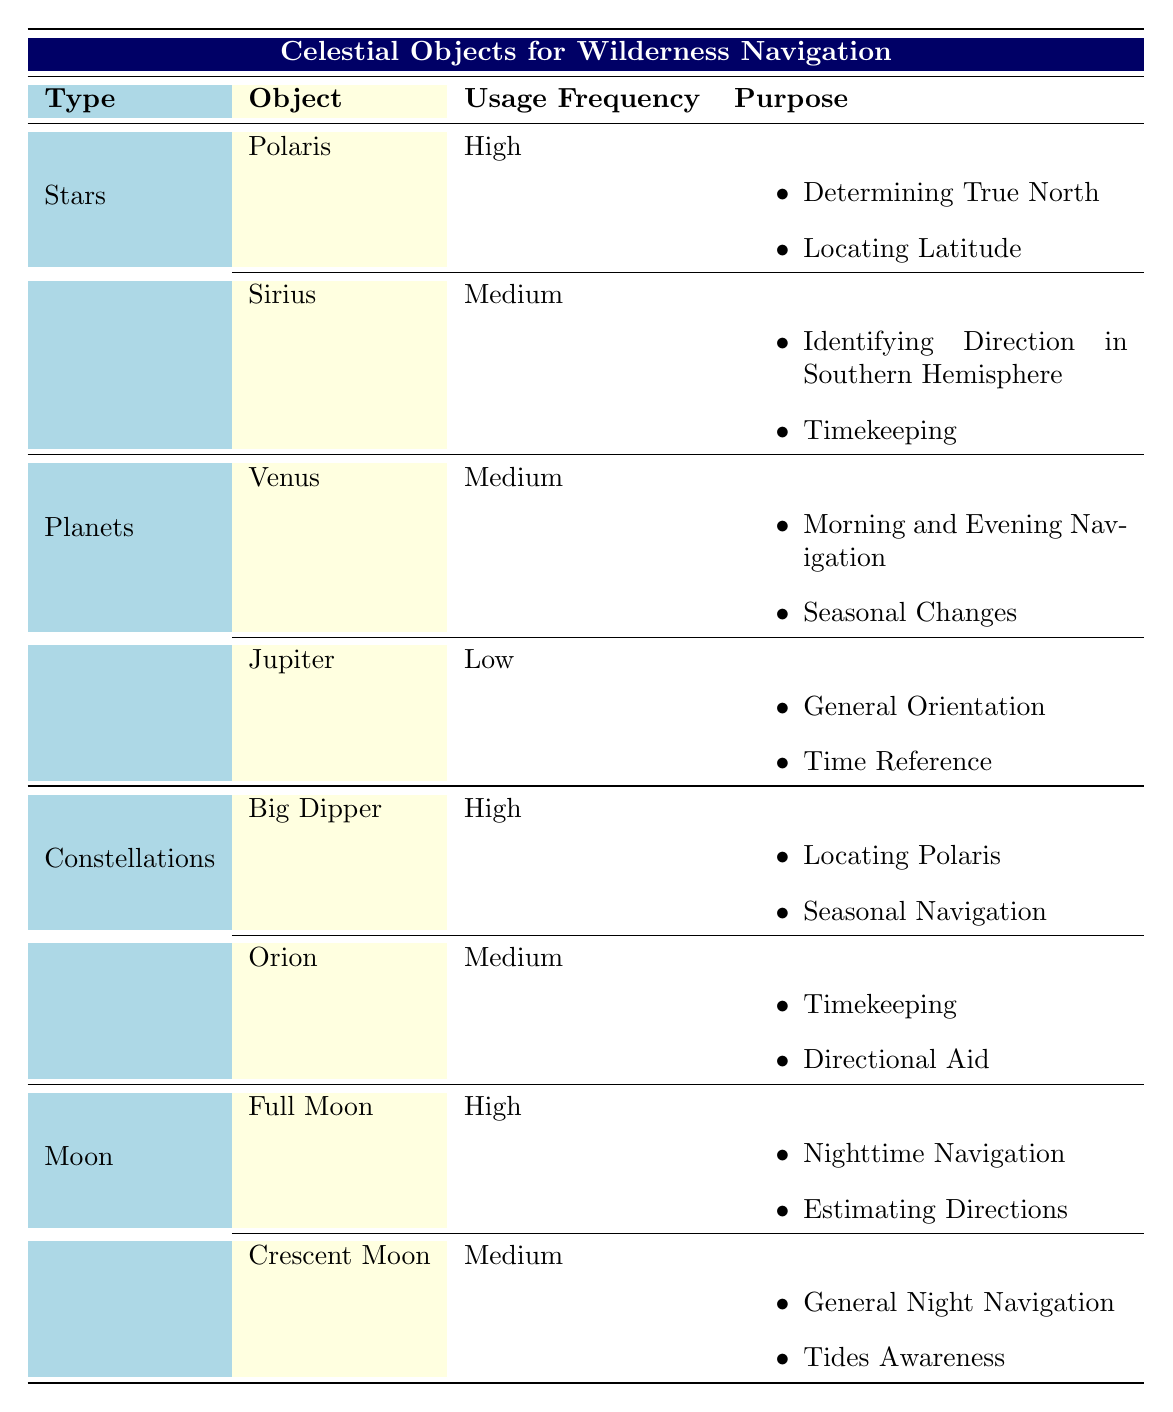What is the usage frequency of Polaris? According to the table, Polaris is categorized under "Stars" and its usage frequency is listed as "High."
Answer: High Which celestial object has a low usage frequency? The table shows that Jupiter, categorized under "Planets," has a usage frequency labeled as "Low."
Answer: Jupiter How many celestial objects have a high usage frequency? From the table, Polaris, Big Dipper, and Full Moon are the celestial objects that are categorized with a "High" usage frequency. Hence, there are three such objects.
Answer: 3 Is Sirius used for timekeeping? The table indicates that Sirius has a "Medium" usage frequency and is used for "Timekeeping," so the statement is true.
Answer: Yes What are the purposes of Venus? For Venus, listed under "Planets," the purposes are "Morning and Evening Navigation" and "Seasonal Changes."
Answer: Morning and Evening Navigation, Seasonal Changes Which celestial type has both its objects with medium usage frequency? According to the table, under the category of "Planets," both Venus and Jupiter have usage frequencies of "Medium." Hence, it is "Planets."
Answer: Planets If you sum the number of high usage frequencies, what would it be? The high usage frequency objects are Polaris, Big Dipper, and Full Moon. There are 3 objects with high usage frequency, resulting in a total sum of 3.
Answer: 3 What are the purposes of the Full Moon? The Full Moon, categorized under "Moon," is used for "Nighttime Navigation" and "Estimating Directions."
Answer: Nighttime Navigation, Estimating Directions Which object is primarily for locating Polaris? The Big Dipper serves the purpose of "Locating Polaris," and it is categorized under "Constellations."
Answer: Big Dipper Does the Crescent Moon have any high usage frequency? The table shows that the Crescent Moon is listed as having a "Medium" usage frequency, not high, indicating the statement is false.
Answer: No 